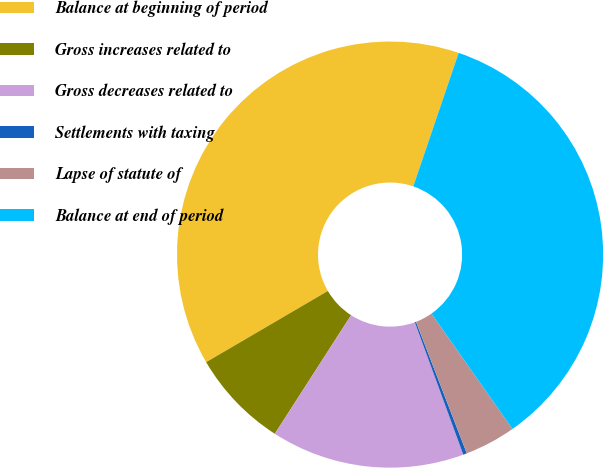<chart> <loc_0><loc_0><loc_500><loc_500><pie_chart><fcel>Balance at beginning of period<fcel>Gross increases related to<fcel>Gross decreases related to<fcel>Settlements with taxing<fcel>Lapse of statute of<fcel>Balance at end of period<nl><fcel>38.64%<fcel>7.48%<fcel>14.68%<fcel>0.28%<fcel>3.88%<fcel>35.04%<nl></chart> 